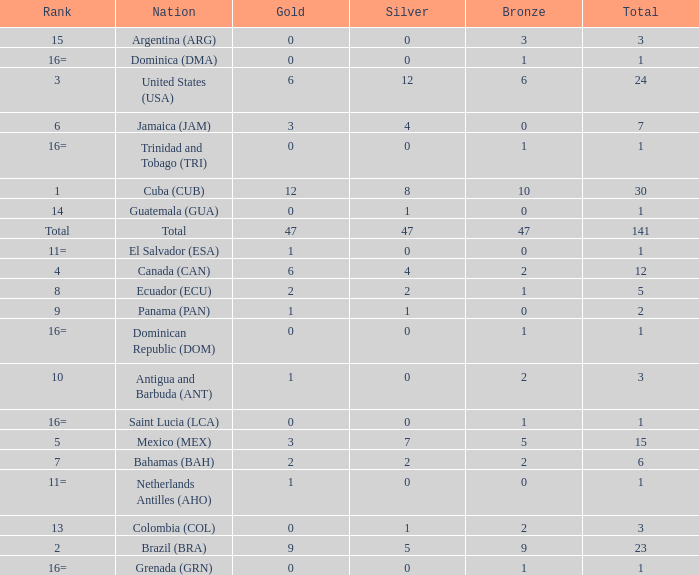How many bronzes have a Nation of jamaica (jam), and a Total smaller than 7? 0.0. 